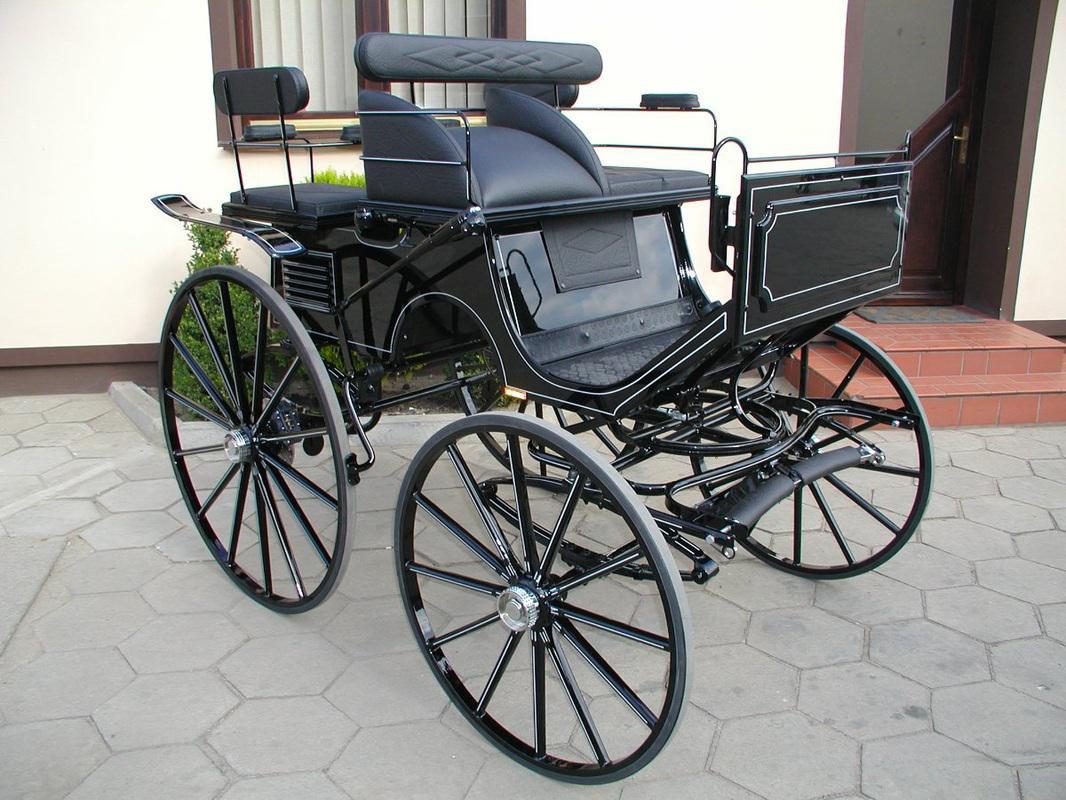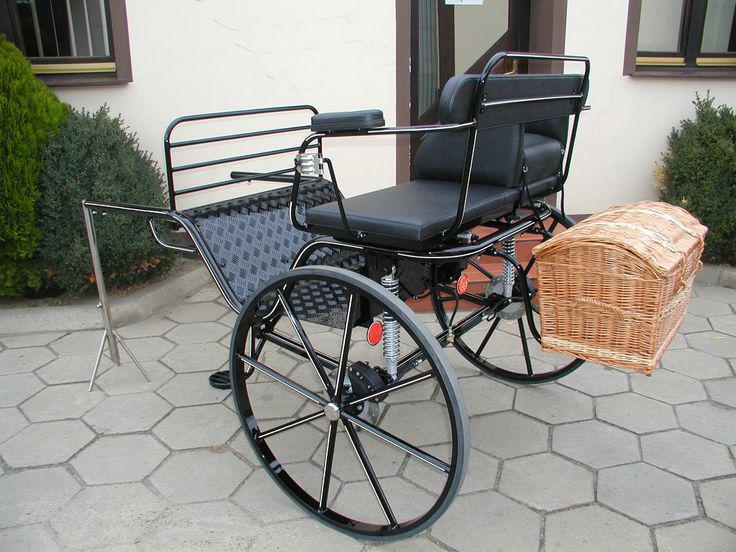The first image is the image on the left, the second image is the image on the right. Assess this claim about the two images: "The carriage on the right most image has yellow wheels.". Correct or not? Answer yes or no. No. The first image is the image on the left, the second image is the image on the right. Examine the images to the left and right. Is the description "Left image features a four-wheeled black cart." accurate? Answer yes or no. Yes. 